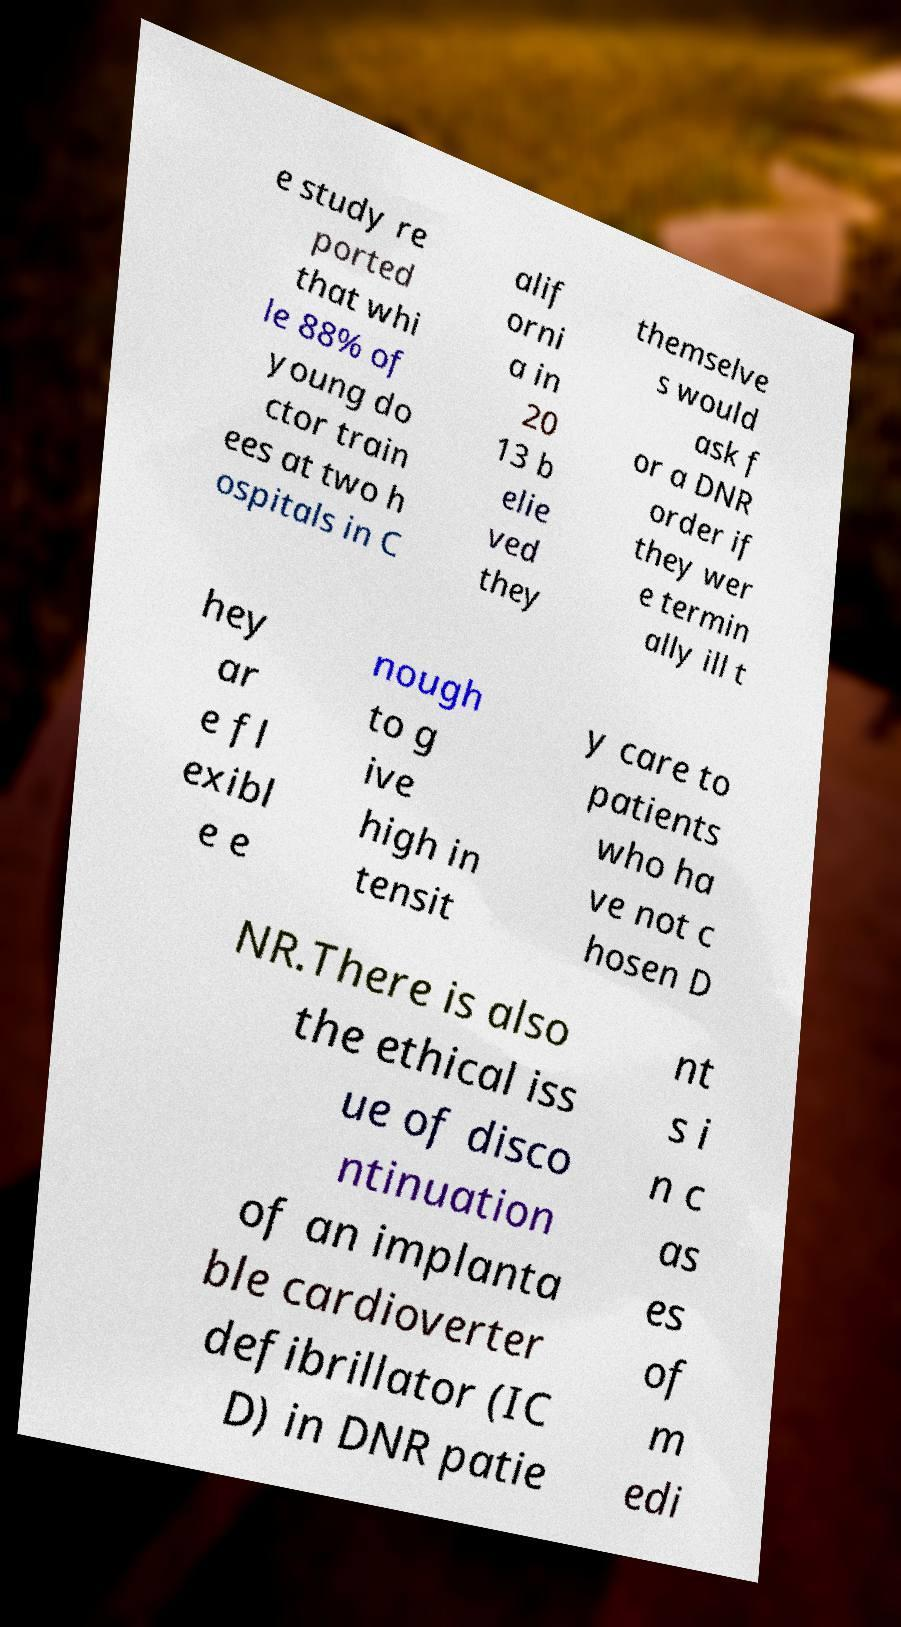Can you read and provide the text displayed in the image?This photo seems to have some interesting text. Can you extract and type it out for me? e study re ported that whi le 88% of young do ctor train ees at two h ospitals in C alif orni a in 20 13 b elie ved they themselve s would ask f or a DNR order if they wer e termin ally ill t hey ar e fl exibl e e nough to g ive high in tensit y care to patients who ha ve not c hosen D NR.There is also the ethical iss ue of disco ntinuation of an implanta ble cardioverter defibrillator (IC D) in DNR patie nt s i n c as es of m edi 